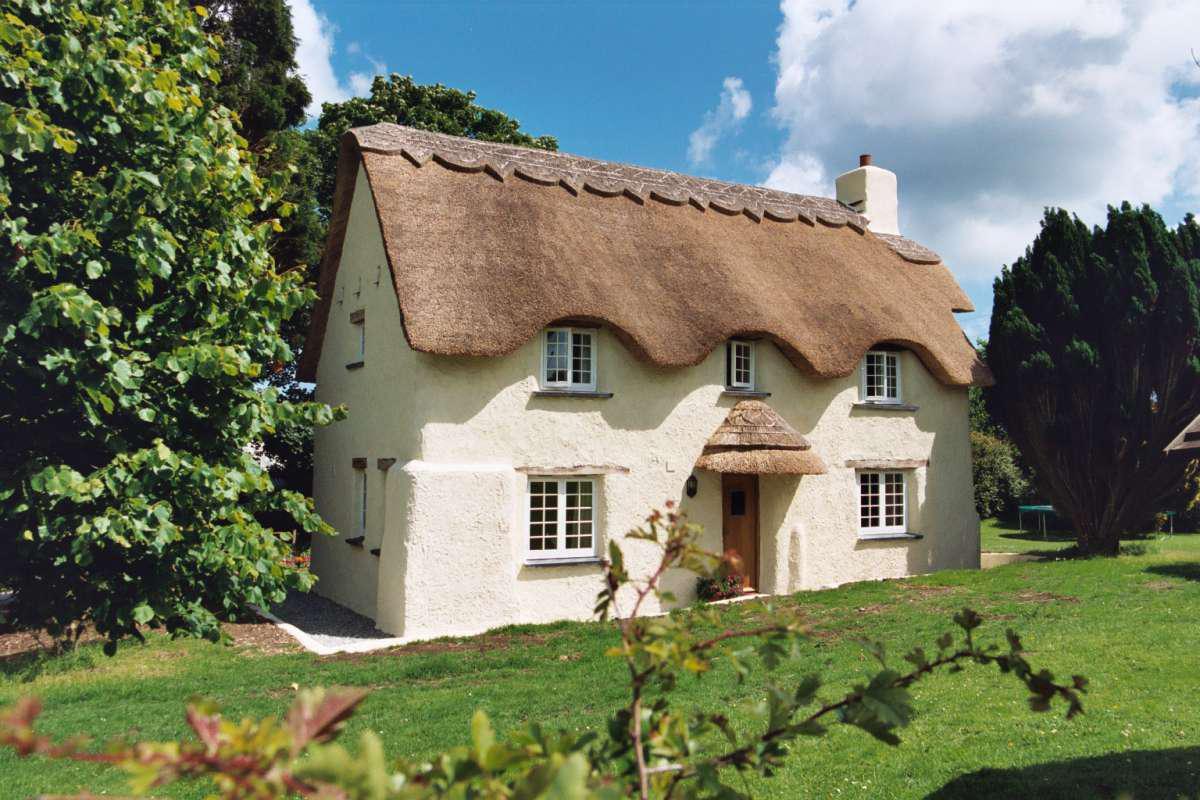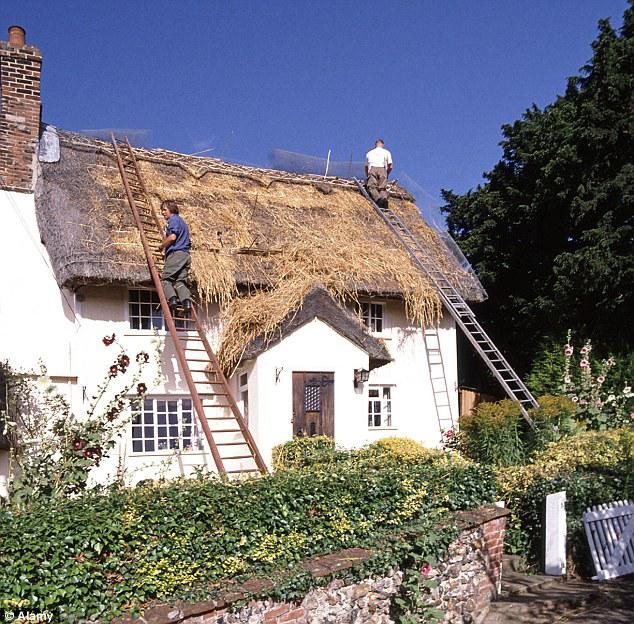The first image is the image on the left, the second image is the image on the right. Examine the images to the left and right. Is the description "At least two humans are visible." accurate? Answer yes or no. Yes. The first image is the image on the left, the second image is the image on the right. For the images shown, is this caption "In at least one image there is a house with only one chimney on the right side." true? Answer yes or no. Yes. 